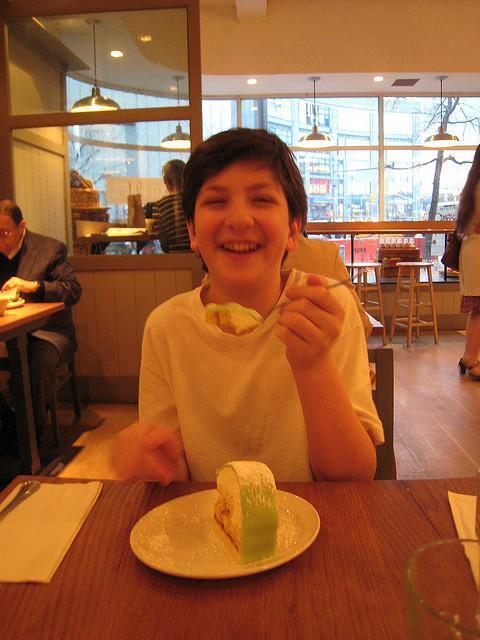How many chairs can you see?
Give a very brief answer. 2. How many people are in the picture?
Give a very brief answer. 4. How many zebras have their faces showing in the image?
Give a very brief answer. 0. 